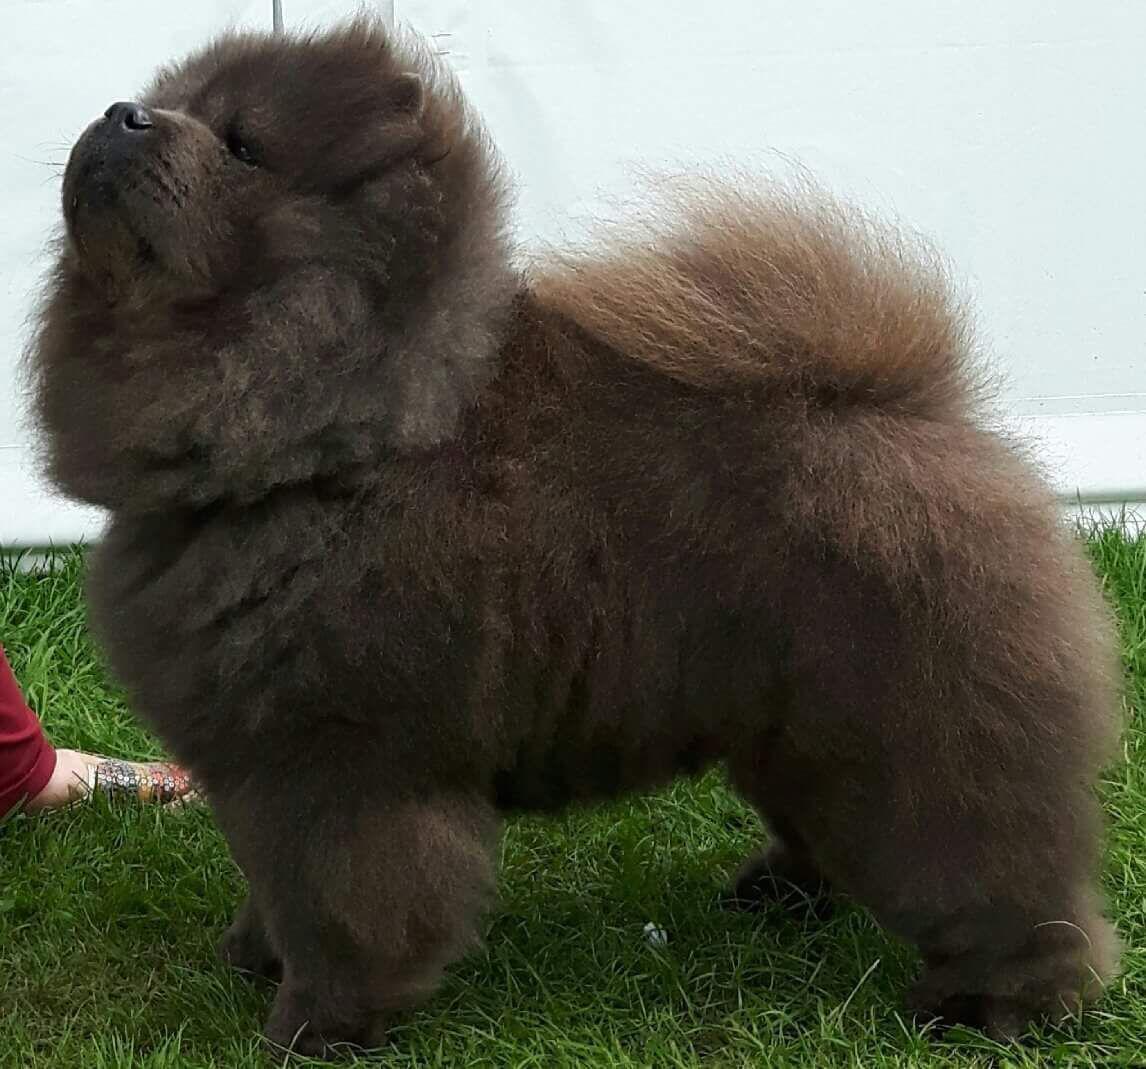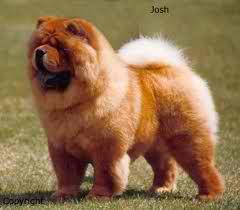The first image is the image on the left, the second image is the image on the right. Given the left and right images, does the statement "There two dogs in total." hold true? Answer yes or no. Yes. The first image is the image on the left, the second image is the image on the right. For the images displayed, is the sentence "Each image contains exactly one chow dog, and at least one image shows a dog standing in profile on grass." factually correct? Answer yes or no. Yes. 